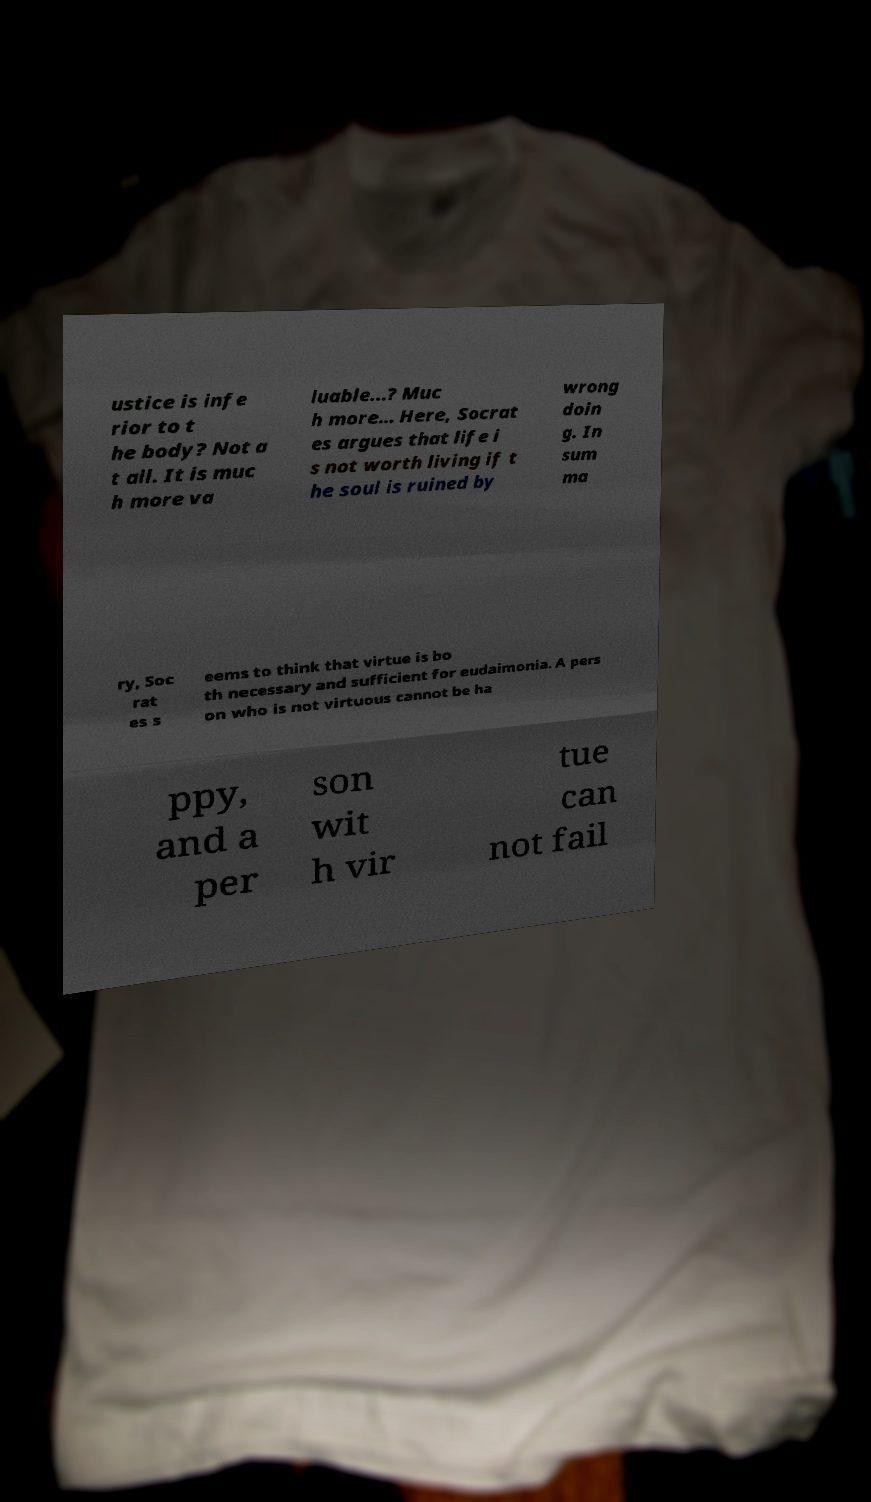Could you assist in decoding the text presented in this image and type it out clearly? ustice is infe rior to t he body? Not a t all. It is muc h more va luable…? Muc h more… Here, Socrat es argues that life i s not worth living if t he soul is ruined by wrong doin g. In sum ma ry, Soc rat es s eems to think that virtue is bo th necessary and sufficient for eudaimonia. A pers on who is not virtuous cannot be ha ppy, and a per son wit h vir tue can not fail 